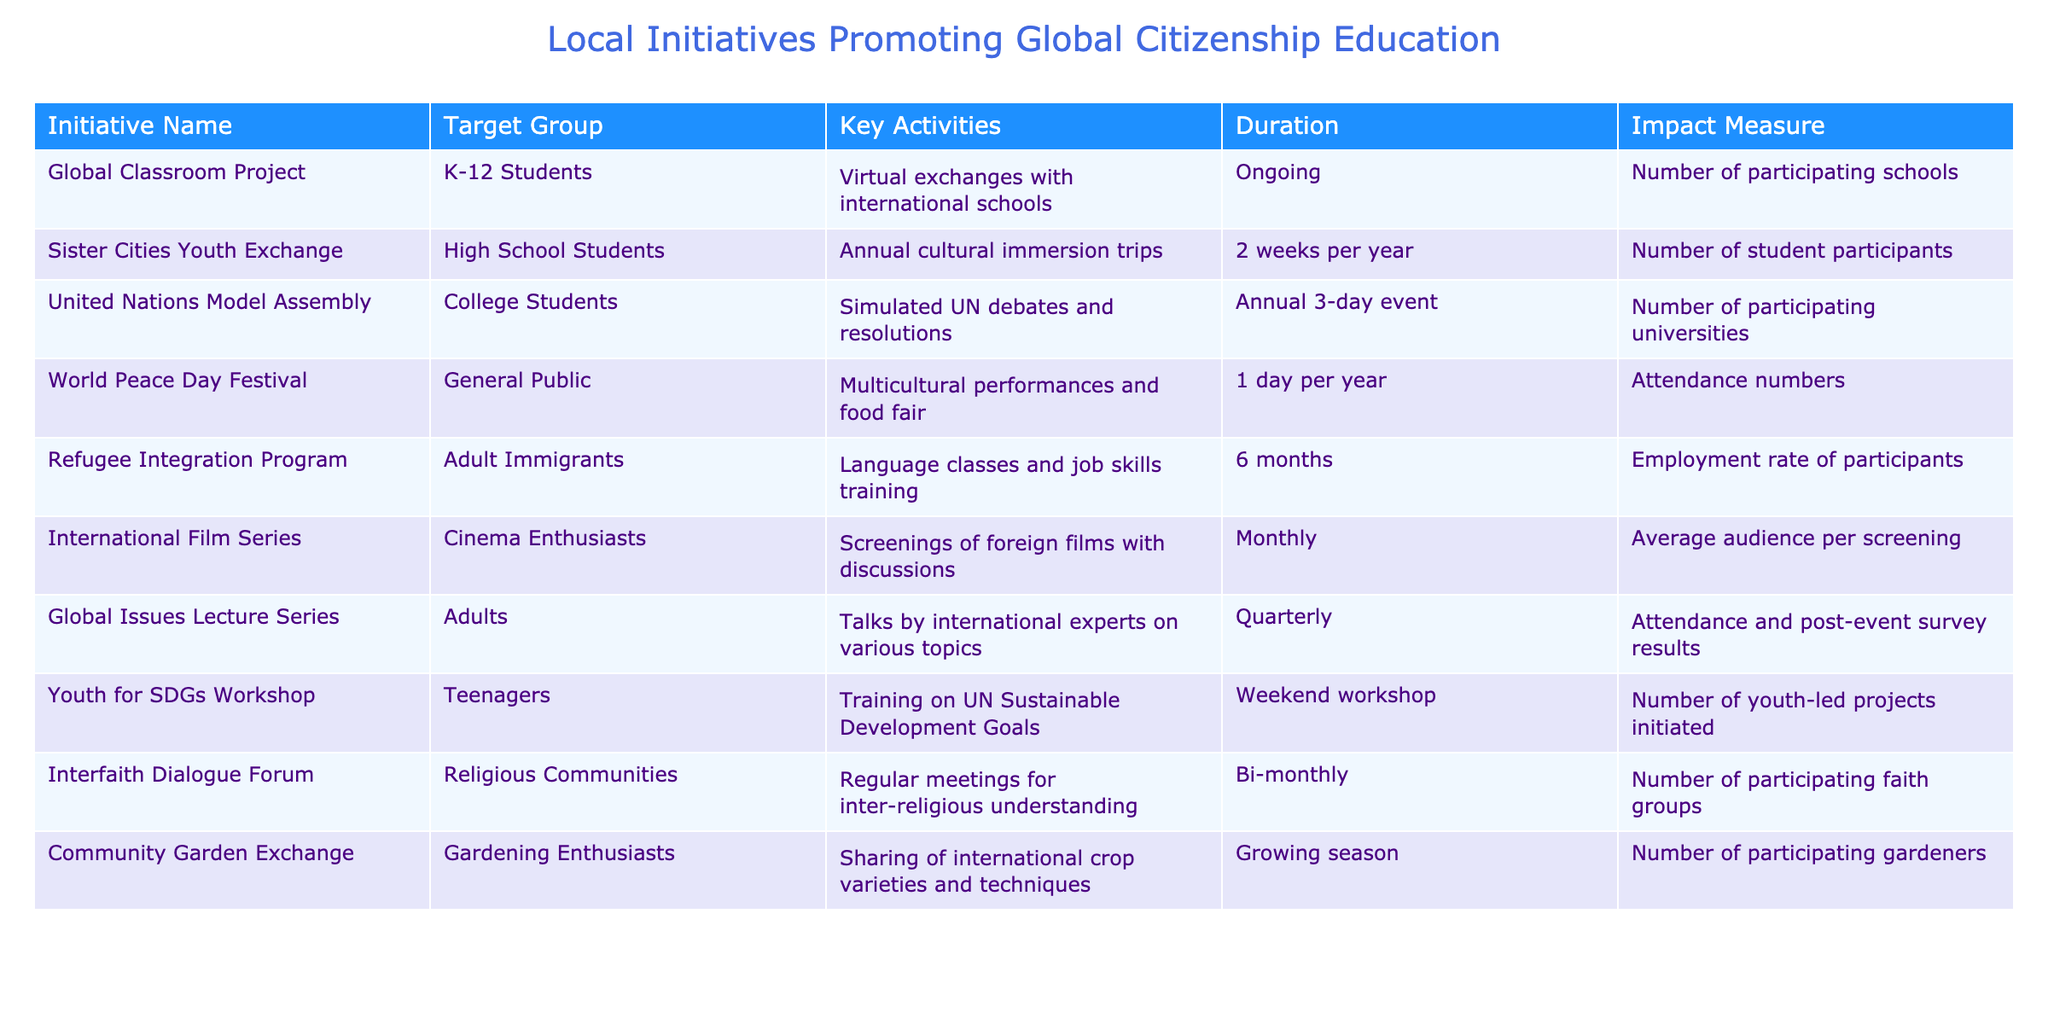What is the duration of the Sister Cities Youth Exchange initiative? The duration of the Sister Cities Youth Exchange initiative is specified in the table as "2 weeks per year."
Answer: 2 weeks per year Which target group is involved in the Global Classroom Project? The target group for the Global Classroom Project is listed as "K-12 Students" in the table.
Answer: K-12 Students How many times does the International Film Series occur in a year? The International Film Series is scheduled "Monthly," which means it occurs 12 times in a year (one for each month).
Answer: 12 times Is the World Peace Day Festival focused on a specific age group? The World Peace Day Festival targets the "General Public," indicating that it is not limited to a specific age group.
Answer: No What is the impact measure for the Refugee Integration Program? The impact measure for the Refugee Integration Program is the "Employment rate of participants," which provides a metric for its success.
Answer: Employment rate of participants Out of all initiatives, which has the longest duration? The Refugee Integration Program lasts for "6 months," which is longer than other initiatives listed, such as annual or shorter activities.
Answer: 6 months How many different groups are engaged in the Interfaith Dialogue Forum? The Interfaith Dialogue Forum measures its impact by the "Number of participating faith groups," but does not specify an exact quantity, leaving it open-ended in the table.
Answer: Not quantified What is the average duration of the initiatives listed in the table? To find the average, the durations are converted to weeks: Global Classroom Project (Ongoing), Sister Cities Youth Exchange (2 weeks), UN Model Assembly (3 days), World Peace Day Festival (1 day), Refugee Program (6 months = 26 weeks), International Film Series (not specified), etc. Not all durations are easily averaged due to differing time frames.
Answer: Cannot determine Which initiative has a key activity focusing on cultural exchange, and what is its duration? The initiative with a key activity focused on cultural immersion and exchange is the Sister Cities Youth Exchange, with a duration of "2 weeks per year."
Answer: Sister Cities Youth Exchange, 2 weeks per year How does the World Peace Day Festival measure its success? The World Peace Day Festival measures its success using "Attendance numbers" as an impact measure.
Answer: Attendance numbers Is the Global Issues Lecture Series held more frequently than the Youth for SDGs Workshop? The Global Issues Lecture Series is held "Quarterly" (4 times a year), while the Youth for SDGs Workshop occurs "Weekend" (undetermined frequency), hence cannot definitively say one is more frequent without more clarification on the latter.
Answer: Cannot determine 